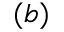Convert formula to latex. <formula><loc_0><loc_0><loc_500><loc_500>( b )</formula> 